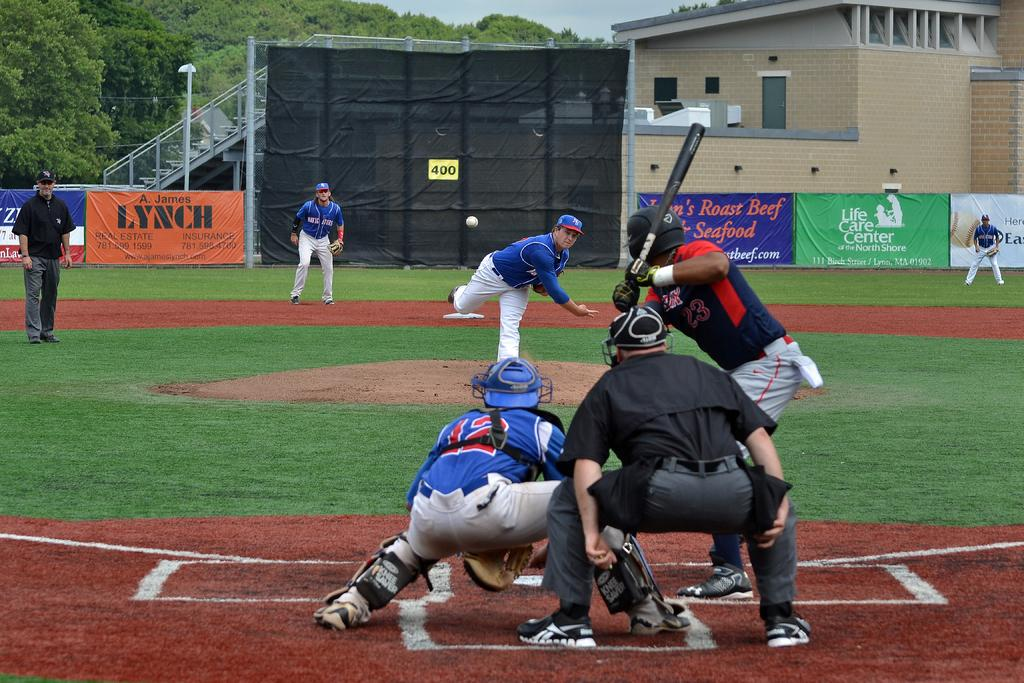<image>
Give a short and clear explanation of the subsequent image. A. James Lynch, estate planner sticks out from other ads on outfield wall of baseball park, players in forground 